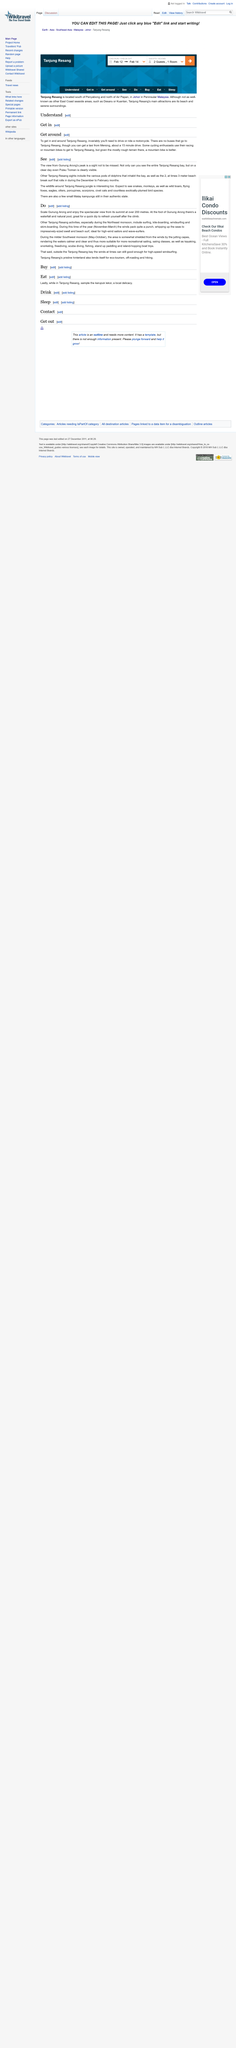Outline some significant characteristics in this image. Gunung Arong's peak offers a stunning view of Tanjung Resang, including the various pods of dolphins that inhabit the bay, as well as the 2 to 3 meter beach break surf that occurs during the December to February months. There are no buses that travel to Tanjung Resang. From the peak of Gunung Arong, one can observe a breathtaking panoramic view of Tanjung Resang Bay, including its surrounding islands and the crystal-clear waters. Furthermore, on a clear day, the distant island of Pulau Tioman can be seen with utmost clarity, providing an awe-inspiring vista of the South China Sea. 